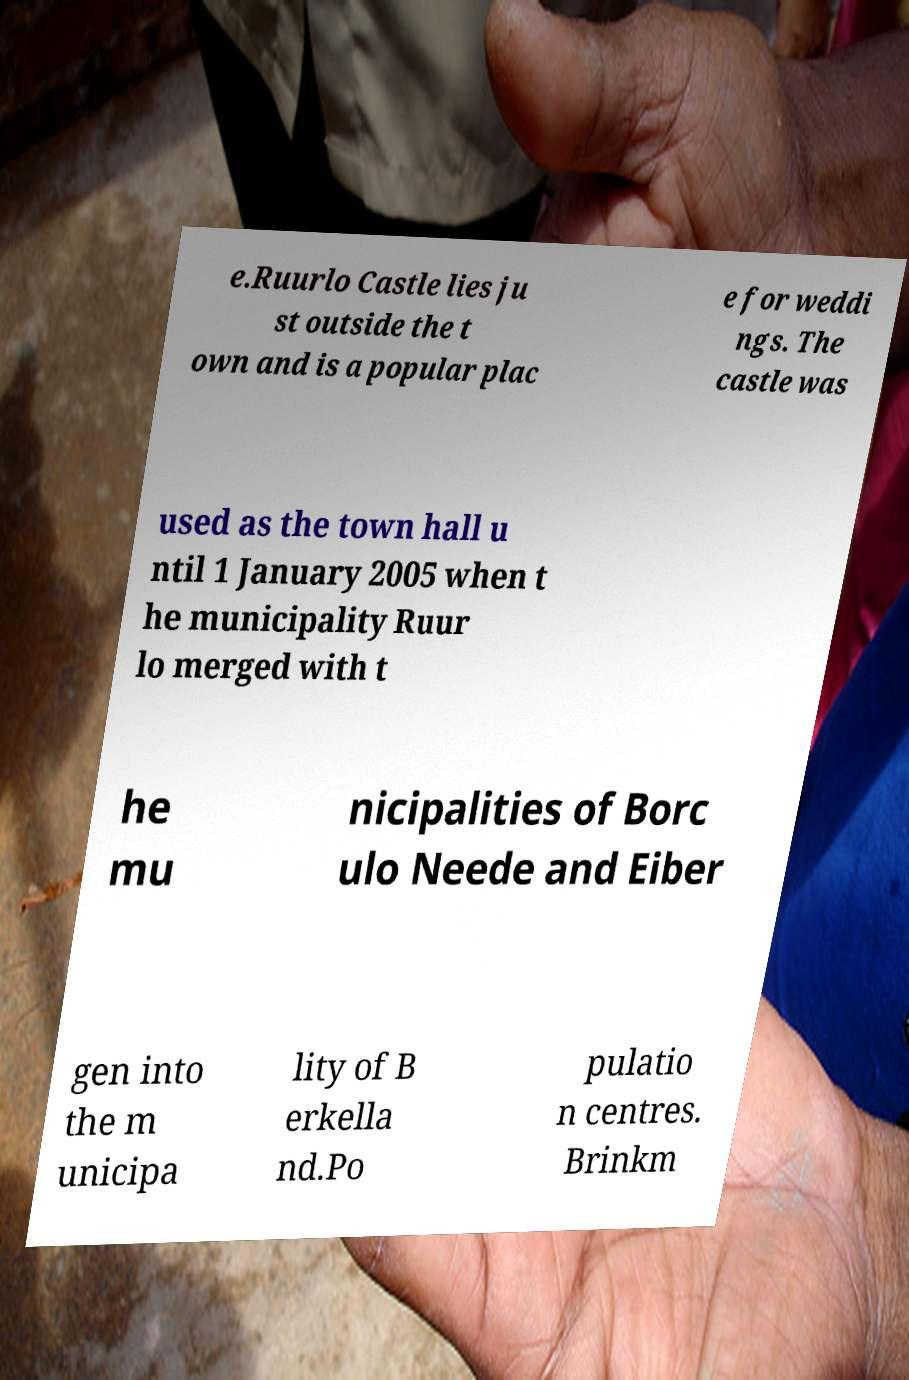Please read and relay the text visible in this image. What does it say? e.Ruurlo Castle lies ju st outside the t own and is a popular plac e for weddi ngs. The castle was used as the town hall u ntil 1 January 2005 when t he municipality Ruur lo merged with t he mu nicipalities of Borc ulo Neede and Eiber gen into the m unicipa lity of B erkella nd.Po pulatio n centres. Brinkm 